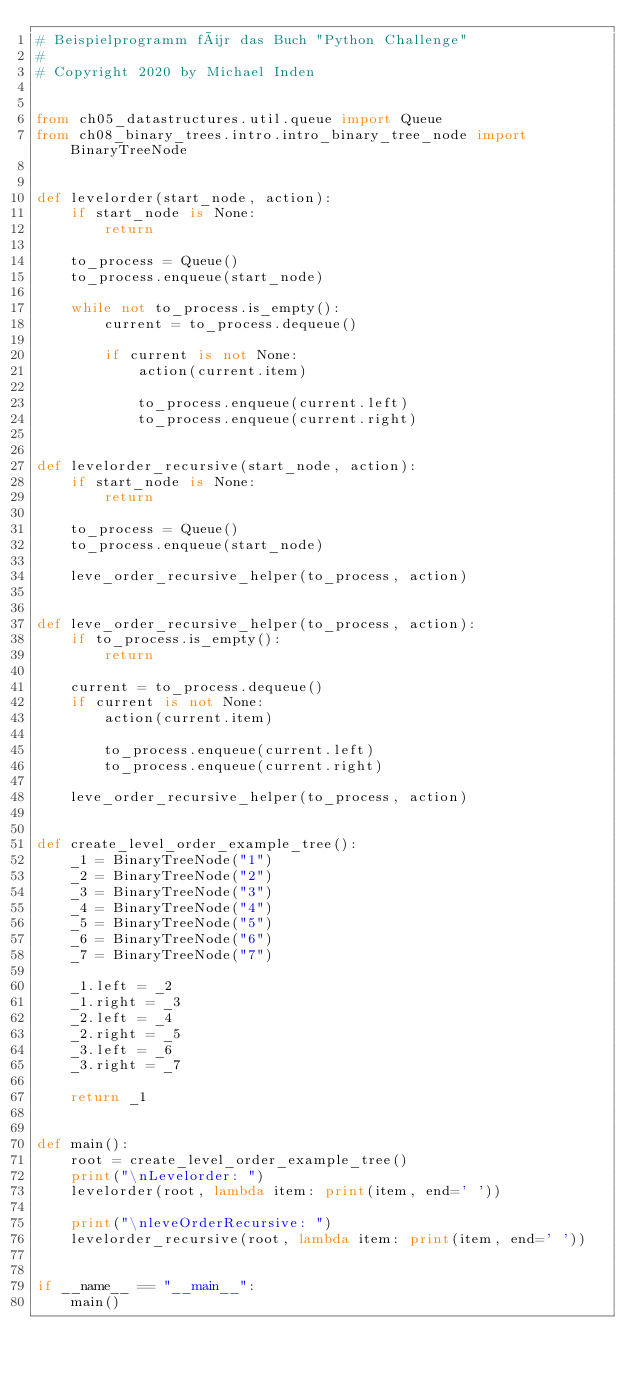Convert code to text. <code><loc_0><loc_0><loc_500><loc_500><_Python_># Beispielprogramm für das Buch "Python Challenge"
#
# Copyright 2020 by Michael Inden


from ch05_datastructures.util.queue import Queue
from ch08_binary_trees.intro.intro_binary_tree_node import BinaryTreeNode


def levelorder(start_node, action):
    if start_node is None:
        return

    to_process = Queue()
    to_process.enqueue(start_node)

    while not to_process.is_empty():
        current = to_process.dequeue()

        if current is not None:
            action(current.item)

            to_process.enqueue(current.left)
            to_process.enqueue(current.right)


def levelorder_recursive(start_node, action):
    if start_node is None:
        return

    to_process = Queue()
    to_process.enqueue(start_node)

    leve_order_recursive_helper(to_process, action)


def leve_order_recursive_helper(to_process, action):
    if to_process.is_empty():
        return

    current = to_process.dequeue()
    if current is not None:
        action(current.item)

        to_process.enqueue(current.left)
        to_process.enqueue(current.right)

    leve_order_recursive_helper(to_process, action)


def create_level_order_example_tree():
    _1 = BinaryTreeNode("1")
    _2 = BinaryTreeNode("2")
    _3 = BinaryTreeNode("3")
    _4 = BinaryTreeNode("4")
    _5 = BinaryTreeNode("5")
    _6 = BinaryTreeNode("6")
    _7 = BinaryTreeNode("7")

    _1.left = _2
    _1.right = _3
    _2.left = _4
    _2.right = _5
    _3.left = _6
    _3.right = _7

    return _1


def main():
    root = create_level_order_example_tree()
    print("\nLevelorder: ")
    levelorder(root, lambda item: print(item, end=' '))

    print("\nleveOrderRecursive: ")
    levelorder_recursive(root, lambda item: print(item, end=' '))


if __name__ == "__main__":
    main()
</code> 